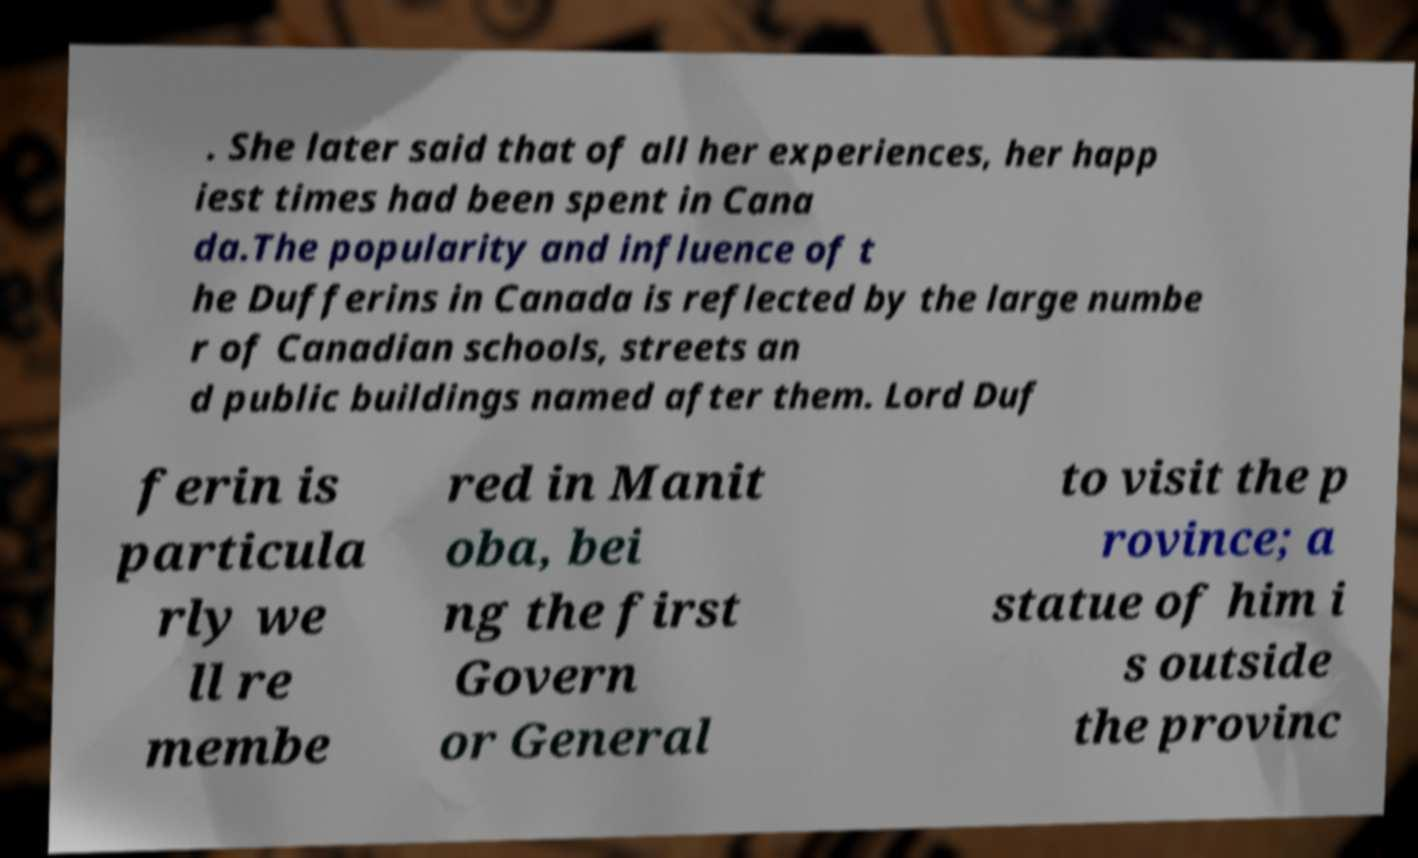For documentation purposes, I need the text within this image transcribed. Could you provide that? . She later said that of all her experiences, her happ iest times had been spent in Cana da.The popularity and influence of t he Dufferins in Canada is reflected by the large numbe r of Canadian schools, streets an d public buildings named after them. Lord Duf ferin is particula rly we ll re membe red in Manit oba, bei ng the first Govern or General to visit the p rovince; a statue of him i s outside the provinc 